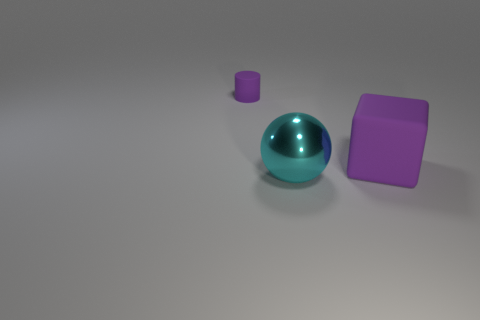Add 2 small purple rubber cylinders. How many objects exist? 5 Subtract all balls. How many objects are left? 2 Add 2 big metallic balls. How many big metallic balls are left? 3 Add 2 purple cubes. How many purple cubes exist? 3 Subtract 0 cyan blocks. How many objects are left? 3 Subtract all cyan objects. Subtract all large yellow cylinders. How many objects are left? 2 